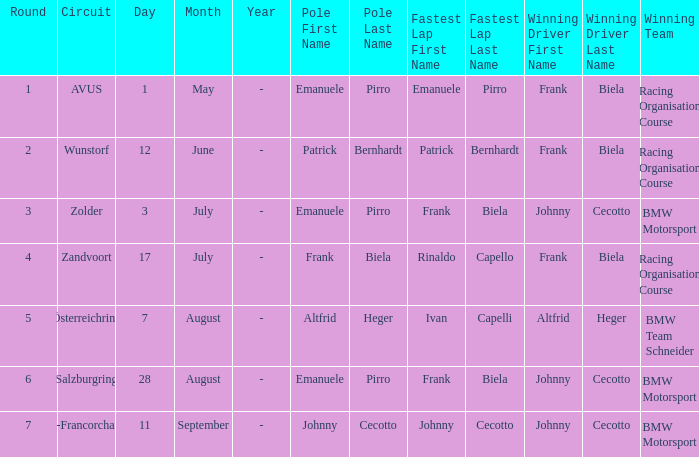Who was the triumphant team at the circuit zolder? BMW Motorsport. Could you help me parse every detail presented in this table? {'header': ['Round', 'Circuit', 'Day', 'Month', 'Year', 'Pole First Name', 'Pole Last Name', 'Fastest Lap First Name', 'Fastest Lap Last Name', 'Winning Driver First Name', 'Winning Driver Last Name', 'Winning Team'], 'rows': [['1', 'AVUS', '1', 'May', '-', 'Emanuele', 'Pirro', 'Emanuele', 'Pirro', 'Frank', 'Biela', 'Racing Organisation Course'], ['2', 'Wunstorf', '12', 'June', '-', 'Patrick', 'Bernhardt', 'Patrick', 'Bernhardt', 'Frank', 'Biela', 'Racing Organisation Course'], ['3', 'Zolder', '3', 'July', '-', 'Emanuele', 'Pirro', 'Frank', 'Biela', 'Johnny', 'Cecotto', 'BMW Motorsport'], ['4', 'Zandvoort', '17', 'July', '-', 'Frank', 'Biela', 'Rinaldo', 'Capello', 'Frank', 'Biela', 'Racing Organisation Course'], ['5', 'Österreichring', '7', 'August', '-', 'Altfrid', 'Heger', 'Ivan', 'Capelli', 'Altfrid', 'Heger', 'BMW Team Schneider'], ['6', 'Salzburgring', '28', 'August', '-', 'Emanuele', 'Pirro', 'Frank', 'Biela', 'Johnny', 'Cecotto', 'BMW Motorsport'], ['7', 'Spa-Francorchamps', '11', 'September', '-', 'Johnny', 'Cecotto', 'Johnny', 'Cecotto', 'Johnny', 'Cecotto', 'BMW Motorsport']]} 